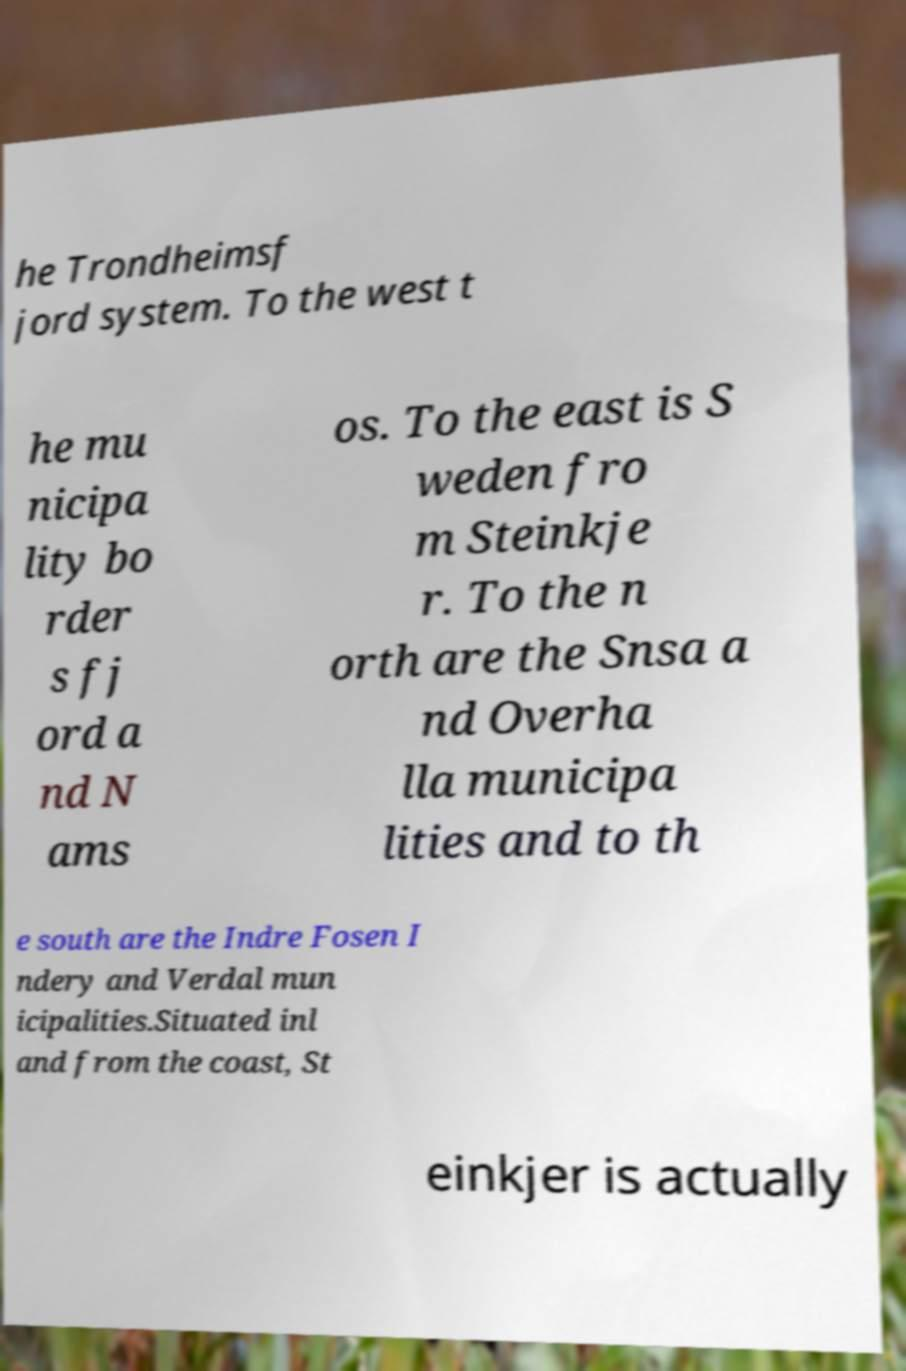Please read and relay the text visible in this image. What does it say? he Trondheimsf jord system. To the west t he mu nicipa lity bo rder s fj ord a nd N ams os. To the east is S weden fro m Steinkje r. To the n orth are the Snsa a nd Overha lla municipa lities and to th e south are the Indre Fosen I ndery and Verdal mun icipalities.Situated inl and from the coast, St einkjer is actually 